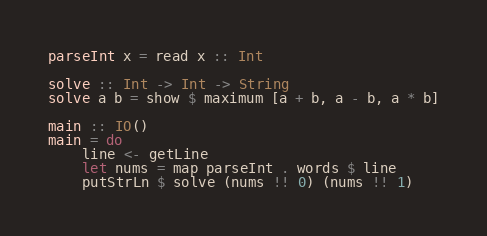<code> <loc_0><loc_0><loc_500><loc_500><_Haskell_>parseInt x = read x :: Int

solve :: Int -> Int -> String
solve a b = show $ maximum [a + b, a - b, a * b]

main :: IO()
main = do
    line <- getLine
    let nums = map parseInt . words $ line
    putStrLn $ solve (nums !! 0) (nums !! 1)</code> 